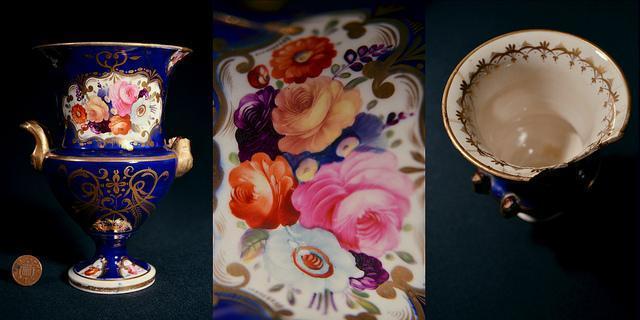How many vases are there?
Give a very brief answer. 3. 